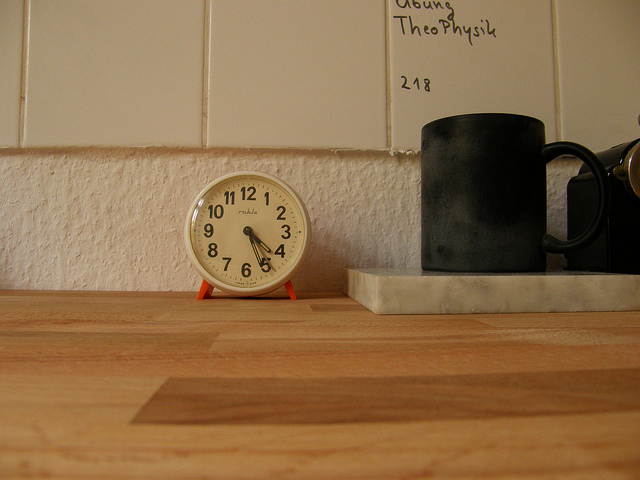Identify the text contained in this image. TheoPhysik 218 11 12 1 2 3 4 5 6 7 8 9 10 